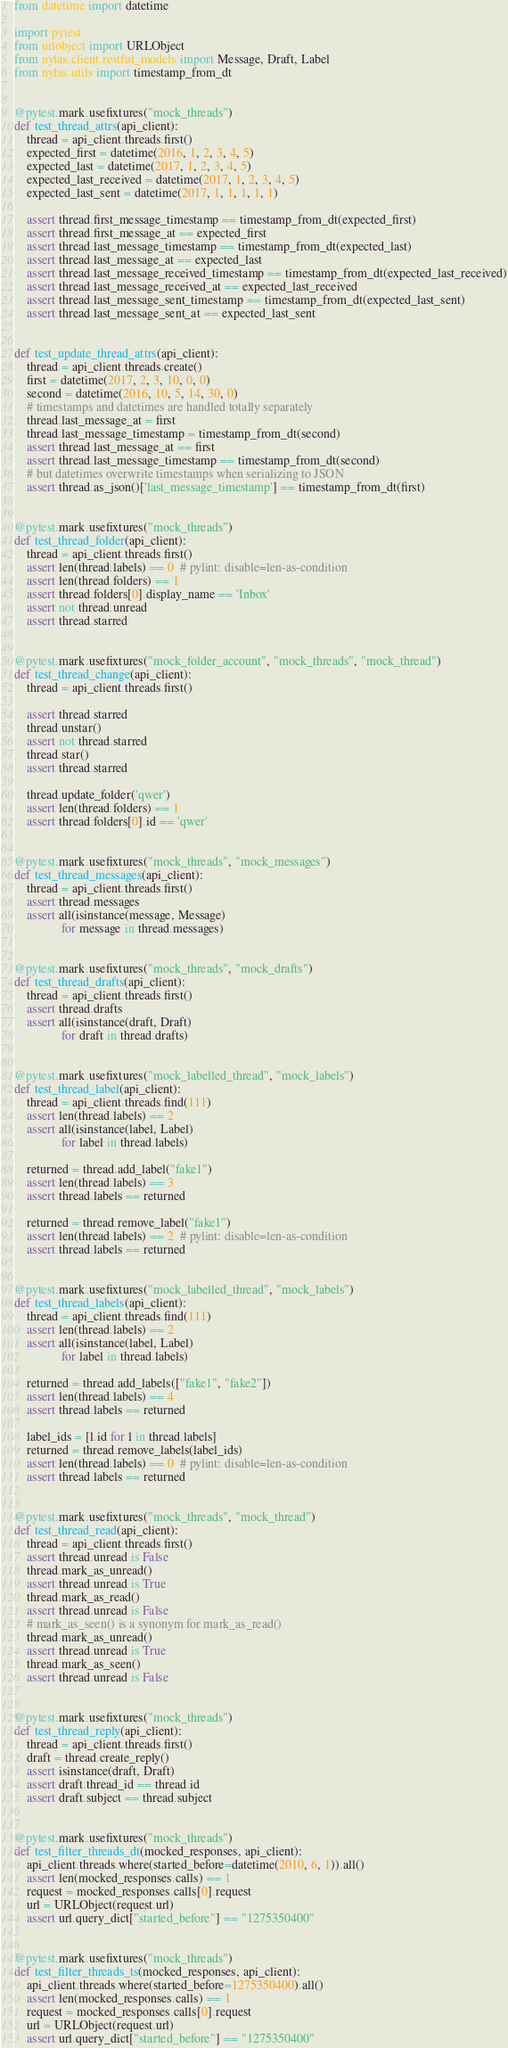<code> <loc_0><loc_0><loc_500><loc_500><_Python_>from datetime import datetime

import pytest
from urlobject import URLObject
from nylas.client.restful_models import Message, Draft, Label
from nylas.utils import timestamp_from_dt


@pytest.mark.usefixtures("mock_threads")
def test_thread_attrs(api_client):
    thread = api_client.threads.first()
    expected_first = datetime(2016, 1, 2, 3, 4, 5)
    expected_last = datetime(2017, 1, 2, 3, 4, 5)
    expected_last_received = datetime(2017, 1, 2, 3, 4, 5)
    expected_last_sent = datetime(2017, 1, 1, 1, 1, 1)

    assert thread.first_message_timestamp == timestamp_from_dt(expected_first)
    assert thread.first_message_at == expected_first
    assert thread.last_message_timestamp == timestamp_from_dt(expected_last)
    assert thread.last_message_at == expected_last
    assert thread.last_message_received_timestamp == timestamp_from_dt(expected_last_received)
    assert thread.last_message_received_at == expected_last_received
    assert thread.last_message_sent_timestamp == timestamp_from_dt(expected_last_sent)
    assert thread.last_message_sent_at == expected_last_sent


def test_update_thread_attrs(api_client):
    thread = api_client.threads.create()
    first = datetime(2017, 2, 3, 10, 0, 0)
    second = datetime(2016, 10, 5, 14, 30, 0)
    # timestamps and datetimes are handled totally separately
    thread.last_message_at = first
    thread.last_message_timestamp = timestamp_from_dt(second)
    assert thread.last_message_at == first
    assert thread.last_message_timestamp == timestamp_from_dt(second)
    # but datetimes overwrite timestamps when serializing to JSON
    assert thread.as_json()['last_message_timestamp'] == timestamp_from_dt(first)


@pytest.mark.usefixtures("mock_threads")
def test_thread_folder(api_client):
    thread = api_client.threads.first()
    assert len(thread.labels) == 0  # pylint: disable=len-as-condition
    assert len(thread.folders) == 1
    assert thread.folders[0].display_name == 'Inbox'
    assert not thread.unread
    assert thread.starred


@pytest.mark.usefixtures("mock_folder_account", "mock_threads", "mock_thread")
def test_thread_change(api_client):
    thread = api_client.threads.first()

    assert thread.starred
    thread.unstar()
    assert not thread.starred
    thread.star()
    assert thread.starred

    thread.update_folder('qwer')
    assert len(thread.folders) == 1
    assert thread.folders[0].id == 'qwer'


@pytest.mark.usefixtures("mock_threads", "mock_messages")
def test_thread_messages(api_client):
    thread = api_client.threads.first()
    assert thread.messages
    assert all(isinstance(message, Message)
               for message in thread.messages)


@pytest.mark.usefixtures("mock_threads", "mock_drafts")
def test_thread_drafts(api_client):
    thread = api_client.threads.first()
    assert thread.drafts
    assert all(isinstance(draft, Draft)
               for draft in thread.drafts)


@pytest.mark.usefixtures("mock_labelled_thread", "mock_labels")
def test_thread_label(api_client):
    thread = api_client.threads.find(111)
    assert len(thread.labels) == 2
    assert all(isinstance(label, Label)
               for label in thread.labels)

    returned = thread.add_label("fake1")
    assert len(thread.labels) == 3
    assert thread.labels == returned

    returned = thread.remove_label("fake1")
    assert len(thread.labels) == 2  # pylint: disable=len-as-condition
    assert thread.labels == returned


@pytest.mark.usefixtures("mock_labelled_thread", "mock_labels")
def test_thread_labels(api_client):
    thread = api_client.threads.find(111)
    assert len(thread.labels) == 2
    assert all(isinstance(label, Label)
               for label in thread.labels)

    returned = thread.add_labels(["fake1", "fake2"])
    assert len(thread.labels) == 4
    assert thread.labels == returned

    label_ids = [l.id for l in thread.labels]
    returned = thread.remove_labels(label_ids)
    assert len(thread.labels) == 0  # pylint: disable=len-as-condition
    assert thread.labels == returned


@pytest.mark.usefixtures("mock_threads", "mock_thread")
def test_thread_read(api_client):
    thread = api_client.threads.first()
    assert thread.unread is False
    thread.mark_as_unread()
    assert thread.unread is True
    thread.mark_as_read()
    assert thread.unread is False
    # mark_as_seen() is a synonym for mark_as_read()
    thread.mark_as_unread()
    assert thread.unread is True
    thread.mark_as_seen()
    assert thread.unread is False


@pytest.mark.usefixtures("mock_threads")
def test_thread_reply(api_client):
    thread = api_client.threads.first()
    draft = thread.create_reply()
    assert isinstance(draft, Draft)
    assert draft.thread_id == thread.id
    assert draft.subject == thread.subject


@pytest.mark.usefixtures("mock_threads")
def test_filter_threads_dt(mocked_responses, api_client):
    api_client.threads.where(started_before=datetime(2010, 6, 1)).all()
    assert len(mocked_responses.calls) == 1
    request = mocked_responses.calls[0].request
    url = URLObject(request.url)
    assert url.query_dict["started_before"] == "1275350400"


@pytest.mark.usefixtures("mock_threads")
def test_filter_threads_ts(mocked_responses, api_client):
    api_client.threads.where(started_before=1275350400).all()
    assert len(mocked_responses.calls) == 1
    request = mocked_responses.calls[0].request
    url = URLObject(request.url)
    assert url.query_dict["started_before"] == "1275350400"
</code> 